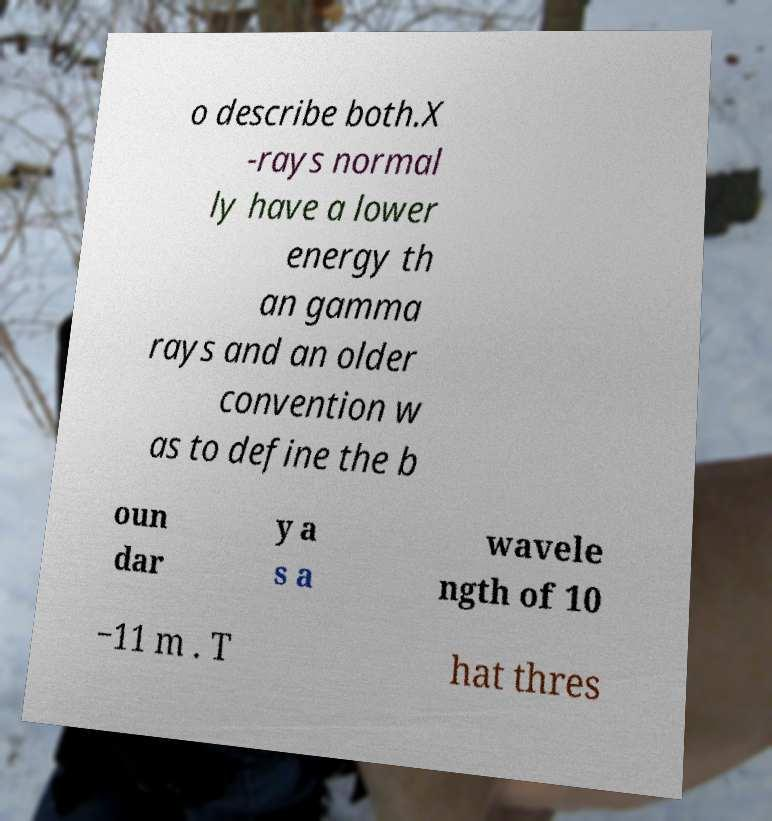There's text embedded in this image that I need extracted. Can you transcribe it verbatim? o describe both.X -rays normal ly have a lower energy th an gamma rays and an older convention w as to define the b oun dar y a s a wavele ngth of 10 −11 m . T hat thres 